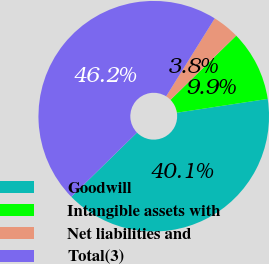Convert chart. <chart><loc_0><loc_0><loc_500><loc_500><pie_chart><fcel>Goodwill<fcel>Intangible assets with<fcel>Net liabilities and<fcel>Total(3)<nl><fcel>40.08%<fcel>9.92%<fcel>3.81%<fcel>46.19%<nl></chart> 